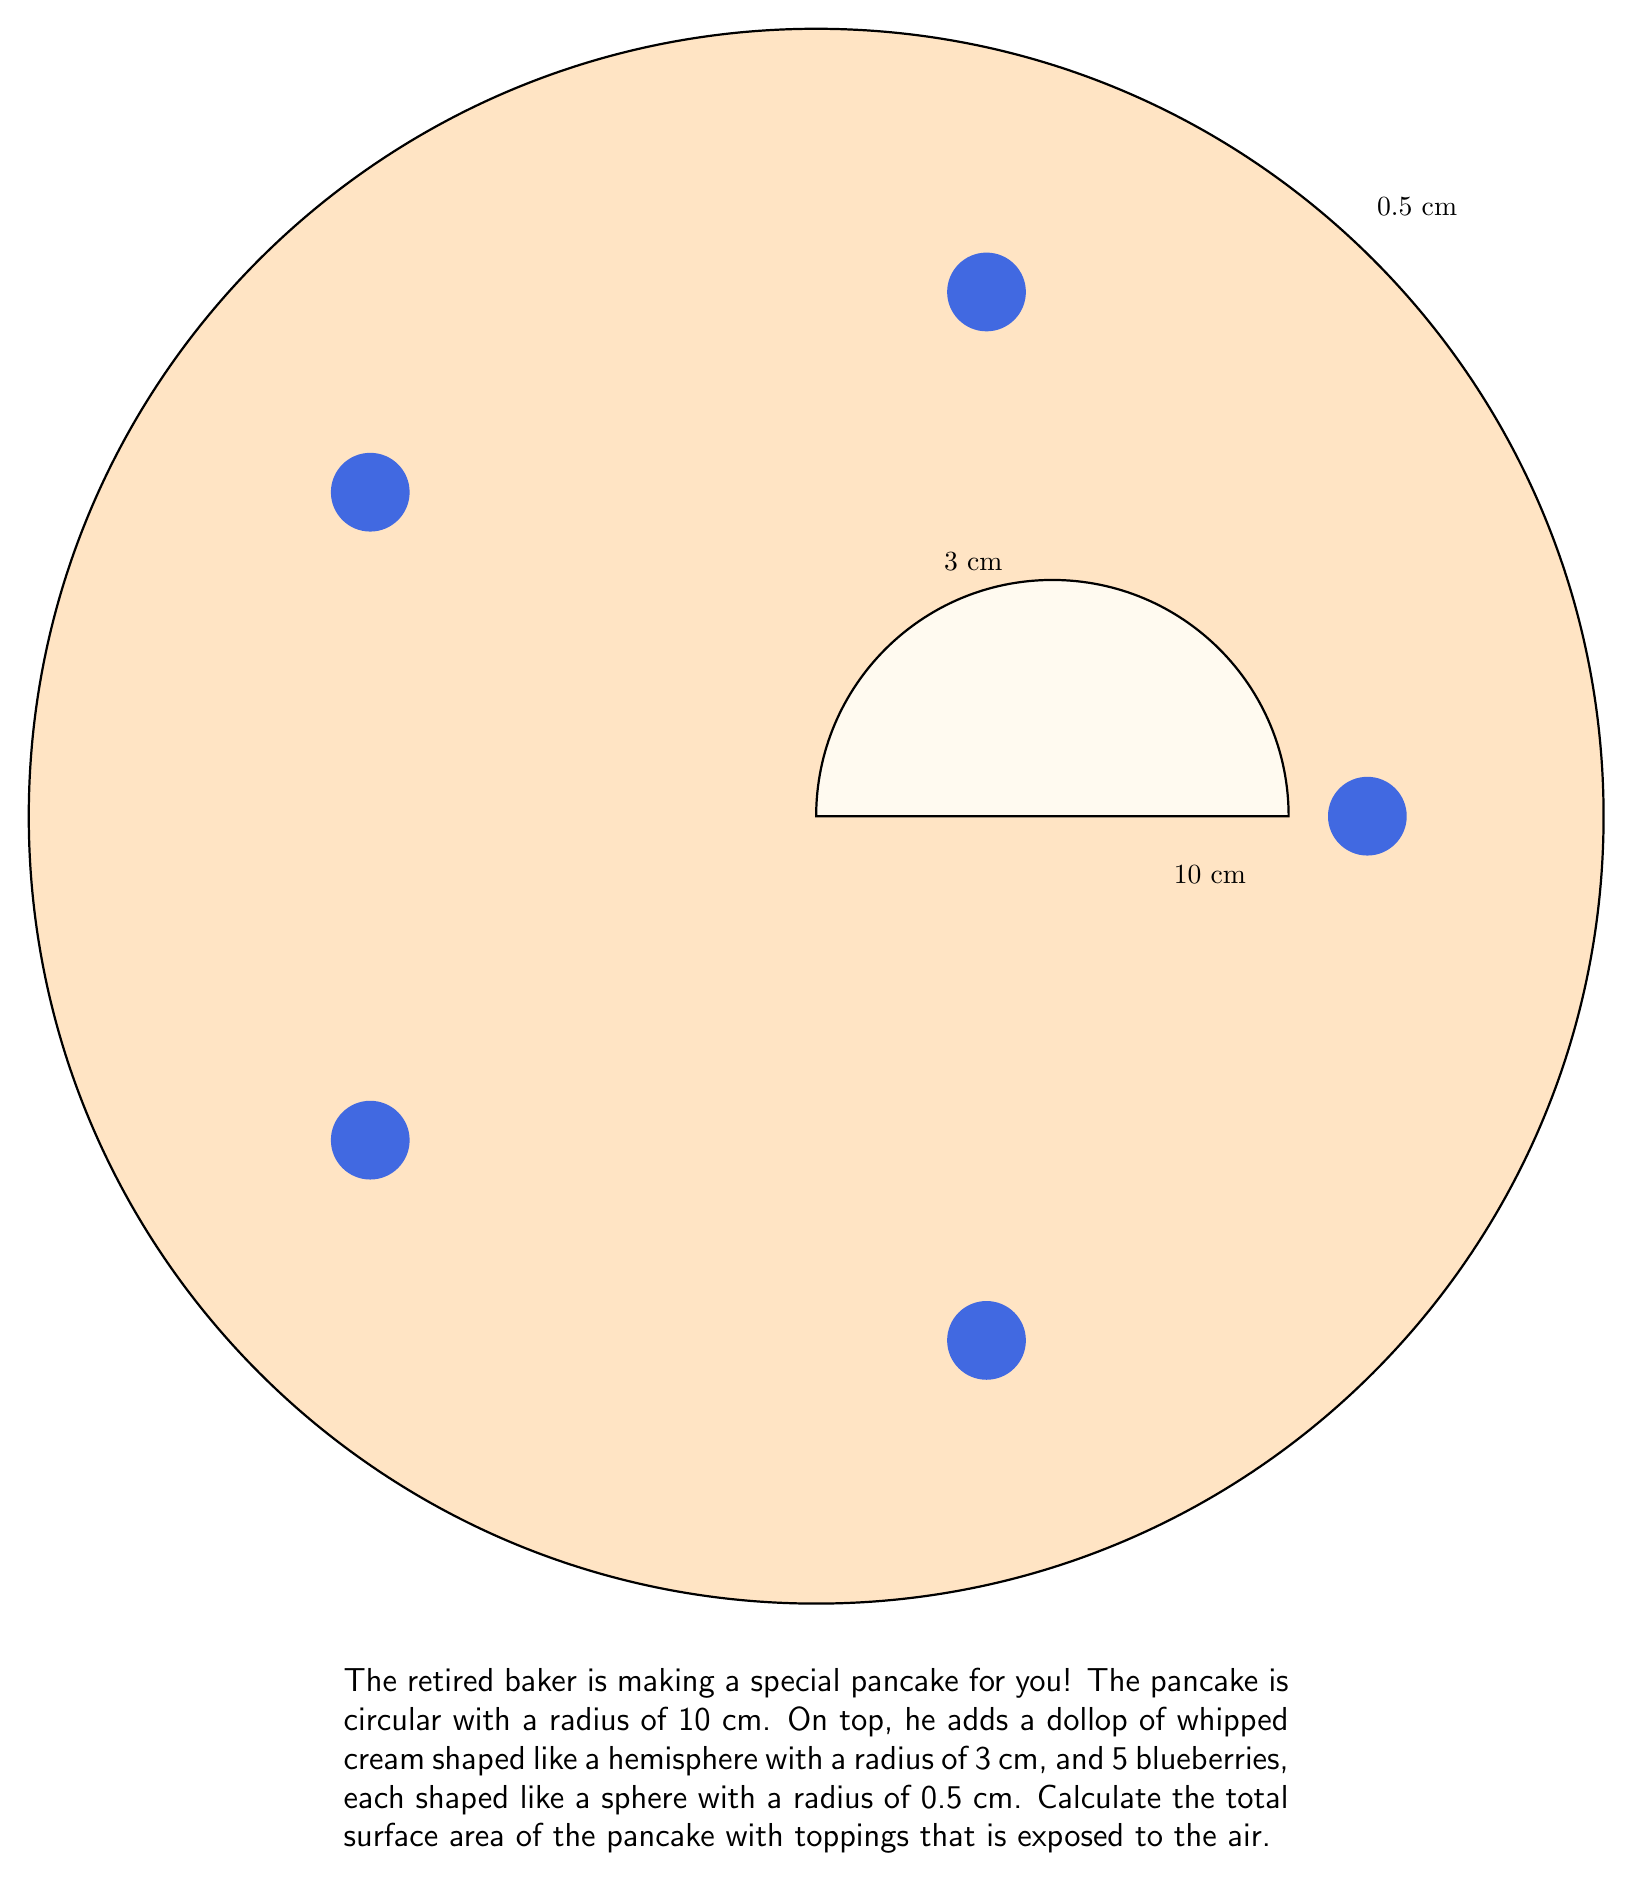Help me with this question. Let's break this down step-by-step:

1) First, calculate the surface area of the circular pancake:
   $$A_{pancake} = \pi r^2 = \pi (10 \text{ cm})^2 = 100\pi \text{ cm}^2$$

2) Next, calculate the surface area of the whipped cream hemisphere:
   $$A_{cream} = 2\pi r^2 = 2\pi (3 \text{ cm})^2 = 18\pi \text{ cm}^2$$

3) Now, calculate the surface area of one blueberry:
   $$A_{blueberry} = 4\pi r^2 = 4\pi (0.5 \text{ cm})^2 = \pi \text{ cm}^2$$

4) There are 5 blueberries, so the total surface area of blueberries is:
   $$A_{allberries} = 5 \cdot \pi \text{ cm}^2 = 5\pi \text{ cm}^2$$

5) However, we need to subtract the area where the toppings touch the pancake:
   - For the whipped cream: $\pi r^2 = \pi (3 \text{ cm})^2 = 9\pi \text{ cm}^2$
   - For each blueberry: $\pi r^2 = \pi (0.5 \text{ cm})^2 = 0.25\pi \text{ cm}^2$
   - Total contact area: $9\pi + 5(0.25\pi) = 10.25\pi \text{ cm}^2$

6) The total exposed surface area is the sum of all areas minus the contact area:
   $$A_{total} = A_{pancake} + A_{cream} + A_{allberries} - A_{contact}$$
   $$A_{total} = 100\pi + 18\pi + 5\pi - 10.25\pi = 112.75\pi \text{ cm}^2$$
Answer: $112.75\pi \text{ cm}^2$ 